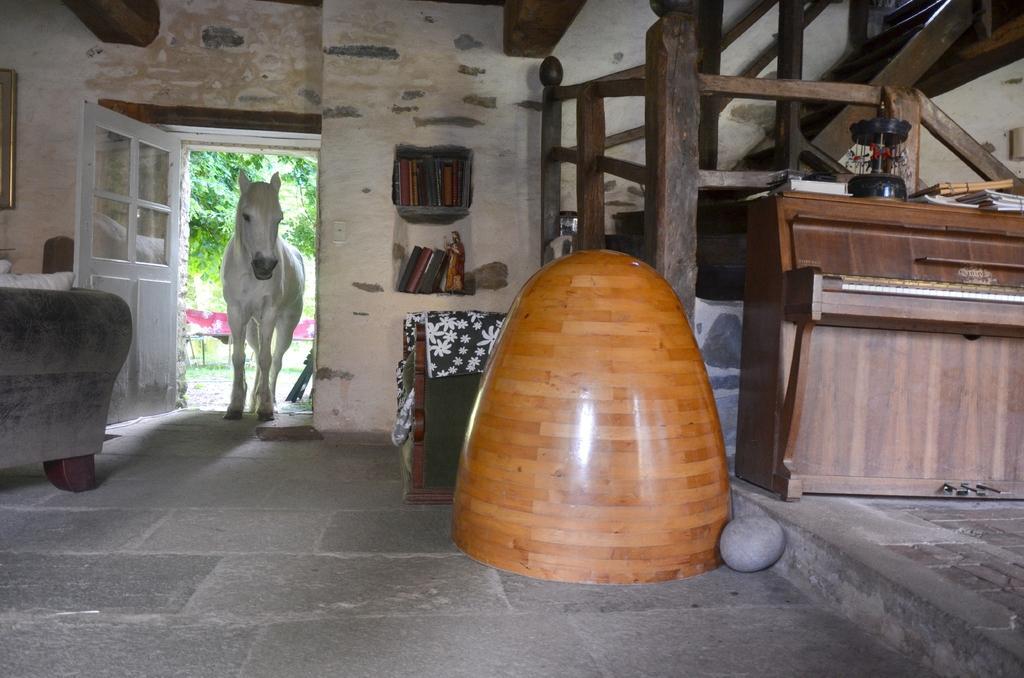Could you give a brief overview of what you see in this image? This picture is clicked inside the room. In front of the picture, we see an object in brown color. Beside that, we see the stone. Behind that, we see the sofa chair. On the right side, we see a table on which black color object and books are placed. Behind that, we see the staircase and the stair railing. On the left side, we see the sofa and a wall on which photo frame is placed. Beside that, we see a white door and a white horse. Behind that, we see the bench and there are trees. Beside that, we see shelves in which books are placed. 